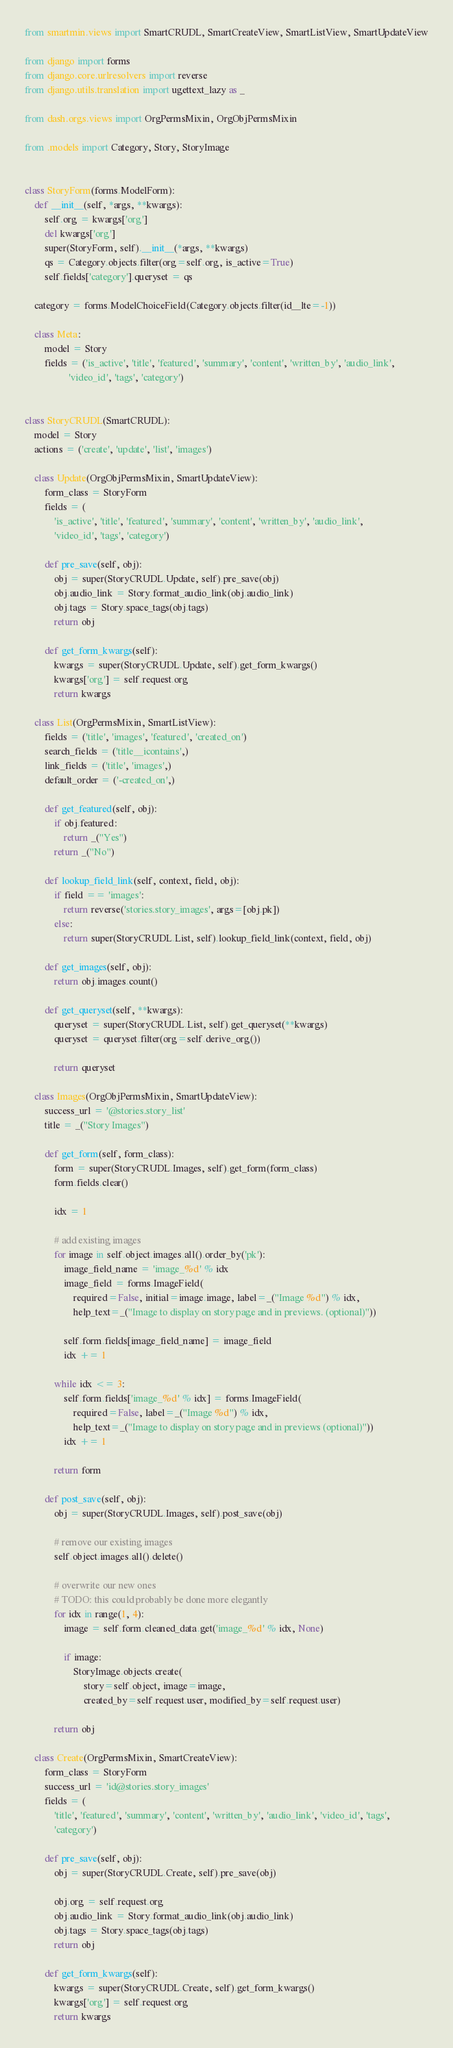Convert code to text. <code><loc_0><loc_0><loc_500><loc_500><_Python_>from smartmin.views import SmartCRUDL, SmartCreateView, SmartListView, SmartUpdateView

from django import forms
from django.core.urlresolvers import reverse
from django.utils.translation import ugettext_lazy as _

from dash.orgs.views import OrgPermsMixin, OrgObjPermsMixin

from .models import Category, Story, StoryImage


class StoryForm(forms.ModelForm):
    def __init__(self, *args, **kwargs):
        self.org = kwargs['org']
        del kwargs['org']
        super(StoryForm, self).__init__(*args, **kwargs)
        qs = Category.objects.filter(org=self.org, is_active=True)
        self.fields['category'].queryset = qs

    category = forms.ModelChoiceField(Category.objects.filter(id__lte=-1))

    class Meta:
        model = Story
        fields = ('is_active', 'title', 'featured', 'summary', 'content', 'written_by', 'audio_link',
                  'video_id', 'tags', 'category')


class StoryCRUDL(SmartCRUDL):
    model = Story
    actions = ('create', 'update', 'list', 'images')

    class Update(OrgObjPermsMixin, SmartUpdateView):
        form_class = StoryForm
        fields = (
            'is_active', 'title', 'featured', 'summary', 'content', 'written_by', 'audio_link',
            'video_id', 'tags', 'category')

        def pre_save(self, obj):
            obj = super(StoryCRUDL.Update, self).pre_save(obj)
            obj.audio_link = Story.format_audio_link(obj.audio_link)
            obj.tags = Story.space_tags(obj.tags)
            return obj

        def get_form_kwargs(self):
            kwargs = super(StoryCRUDL.Update, self).get_form_kwargs()
            kwargs['org'] = self.request.org
            return kwargs

    class List(OrgPermsMixin, SmartListView):
        fields = ('title', 'images', 'featured', 'created_on')
        search_fields = ('title__icontains',)
        link_fields = ('title', 'images',)
        default_order = ('-created_on',)

        def get_featured(self, obj):
            if obj.featured:
                return _("Yes")
            return _("No")

        def lookup_field_link(self, context, field, obj):
            if field == 'images':
                return reverse('stories.story_images', args=[obj.pk])
            else:
                return super(StoryCRUDL.List, self).lookup_field_link(context, field, obj)

        def get_images(self, obj):
            return obj.images.count()

        def get_queryset(self, **kwargs):
            queryset = super(StoryCRUDL.List, self).get_queryset(**kwargs)
            queryset = queryset.filter(org=self.derive_org())

            return queryset

    class Images(OrgObjPermsMixin, SmartUpdateView):
        success_url = '@stories.story_list'
        title = _("Story Images")

        def get_form(self, form_class):
            form = super(StoryCRUDL.Images, self).get_form(form_class)
            form.fields.clear()

            idx = 1

            # add existing images
            for image in self.object.images.all().order_by('pk'):
                image_field_name = 'image_%d' % idx
                image_field = forms.ImageField(
                    required=False, initial=image.image, label=_("Image %d") % idx,
                    help_text=_("Image to display on story page and in previews. (optional)"))

                self.form.fields[image_field_name] = image_field
                idx += 1

            while idx <= 3:
                self.form.fields['image_%d' % idx] = forms.ImageField(
                    required=False, label=_("Image %d") % idx,
                    help_text=_("Image to display on story page and in previews (optional)"))
                idx += 1

            return form

        def post_save(self, obj):
            obj = super(StoryCRUDL.Images, self).post_save(obj)

            # remove our existing images
            self.object.images.all().delete()

            # overwrite our new ones
            # TODO: this could probably be done more elegantly
            for idx in range(1, 4):
                image = self.form.cleaned_data.get('image_%d' % idx, None)

                if image:
                    StoryImage.objects.create(
                        story=self.object, image=image,
                        created_by=self.request.user, modified_by=self.request.user)

            return obj

    class Create(OrgPermsMixin, SmartCreateView):
        form_class = StoryForm
        success_url = 'id@stories.story_images'
        fields = (
            'title', 'featured', 'summary', 'content', 'written_by', 'audio_link', 'video_id', 'tags',
            'category')

        def pre_save(self, obj):
            obj = super(StoryCRUDL.Create, self).pre_save(obj)

            obj.org = self.request.org
            obj.audio_link = Story.format_audio_link(obj.audio_link)
            obj.tags = Story.space_tags(obj.tags)
            return obj

        def get_form_kwargs(self):
            kwargs = super(StoryCRUDL.Create, self).get_form_kwargs()
            kwargs['org'] = self.request.org
            return kwargs
</code> 